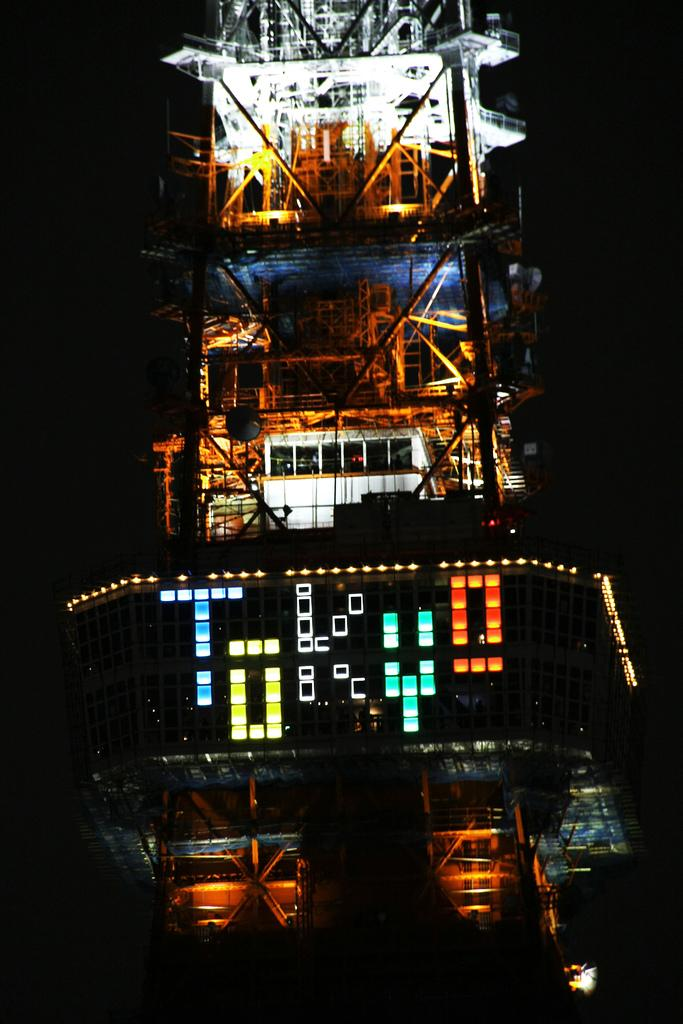What structure is present in the image? There is a building in the image. What feature of the building is mentioned in the facts? The building has lights. What can be observed about the background of the image? The background of the image is dark. What color are the snails crawling on the building in the image? There are no snails present in the image, so it is not possible to determine their color. 